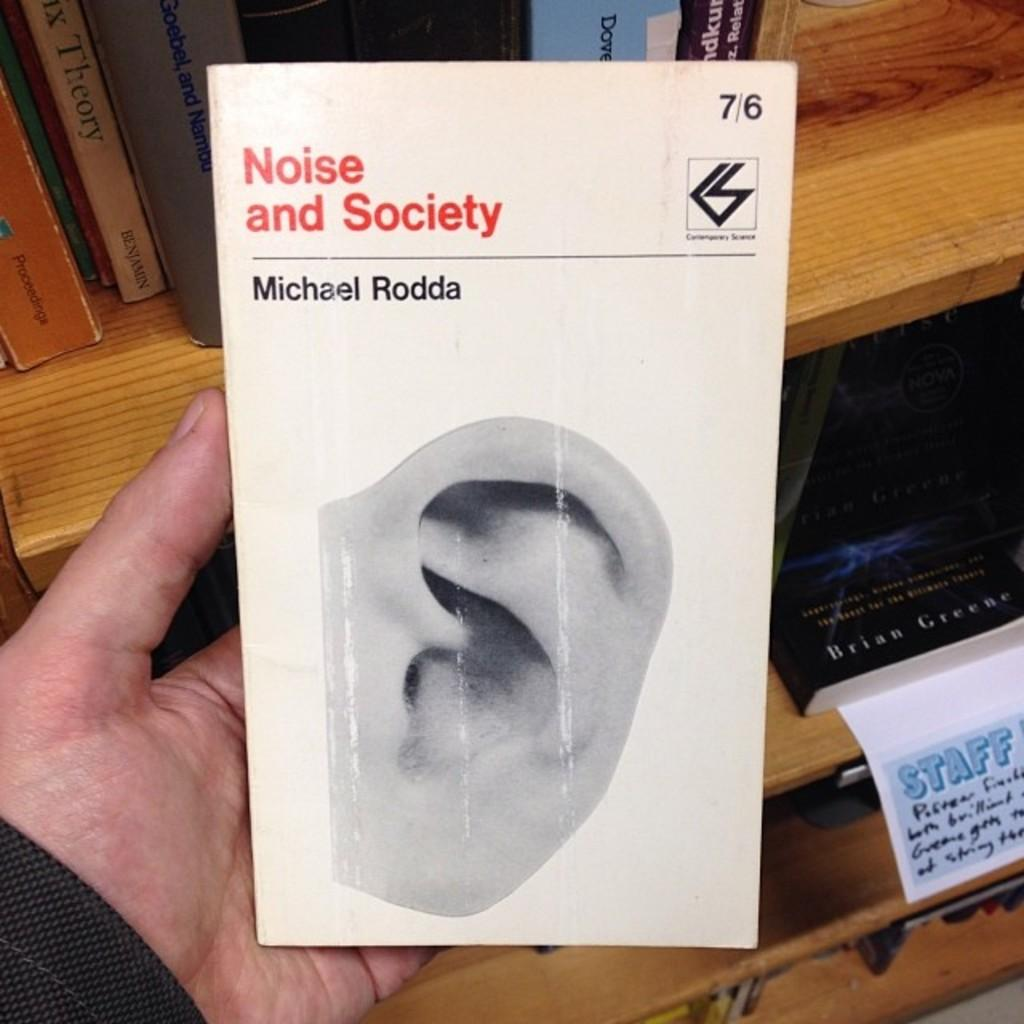<image>
Create a compact narrative representing the image presented. A book with an ear on the cover titled "Noise and Society". 